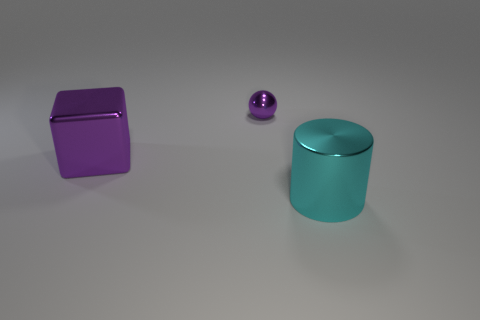Do the large shiny cube and the tiny metal thing have the same color?
Your answer should be very brief. Yes. What size is the purple thing that is made of the same material as the big purple block?
Provide a succinct answer. Small. There is a purple metal sphere; are there any big metallic cylinders to the right of it?
Offer a terse response. Yes. There is a big object in front of the block; is there a big metal block that is to the left of it?
Make the answer very short. Yes. There is a thing in front of the cube; is it the same size as the purple thing to the left of the tiny purple ball?
Keep it short and to the point. Yes. What number of small objects are either purple shiny blocks or cyan cylinders?
Your answer should be compact. 0. There is a large object that is left of the big metal thing on the right side of the cube; what is its material?
Offer a terse response. Metal. There is a large shiny object that is the same color as the small object; what shape is it?
Keep it short and to the point. Cube. Is there a tiny thing that has the same material as the block?
Offer a very short reply. Yes. Do the cube and the large object that is to the right of the tiny purple metal object have the same material?
Provide a succinct answer. Yes. 